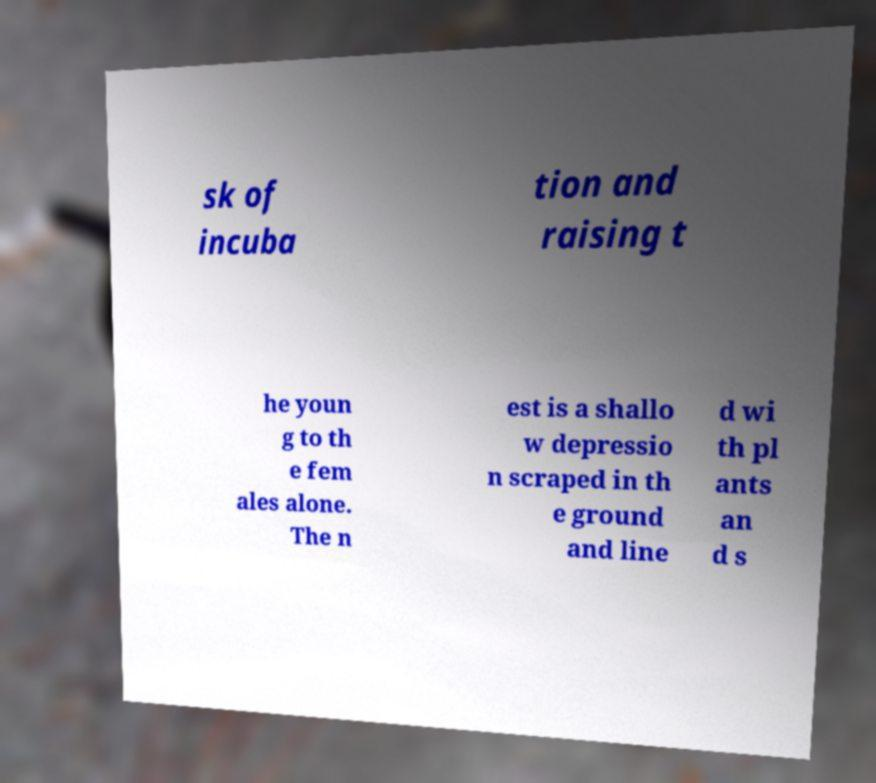Could you assist in decoding the text presented in this image and type it out clearly? sk of incuba tion and raising t he youn g to th e fem ales alone. The n est is a shallo w depressio n scraped in th e ground and line d wi th pl ants an d s 